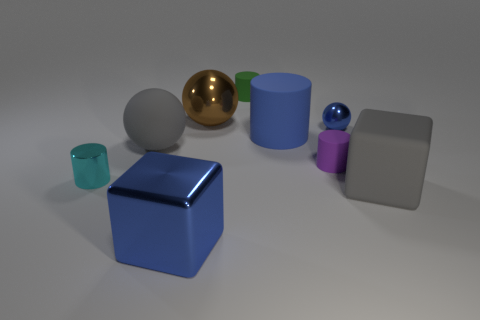Add 1 big cyan things. How many objects exist? 10 Subtract all balls. How many objects are left? 6 Subtract all metal cubes. Subtract all green rubber cylinders. How many objects are left? 7 Add 6 brown things. How many brown things are left? 7 Add 2 tiny gray balls. How many tiny gray balls exist? 2 Subtract 1 brown spheres. How many objects are left? 8 